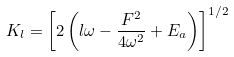<formula> <loc_0><loc_0><loc_500><loc_500>K _ { l } = \left [ 2 \left ( l \omega - \frac { F ^ { 2 } } { 4 \omega ^ { 2 } } + E _ { a } \right ) \right ] ^ { 1 / 2 }</formula> 